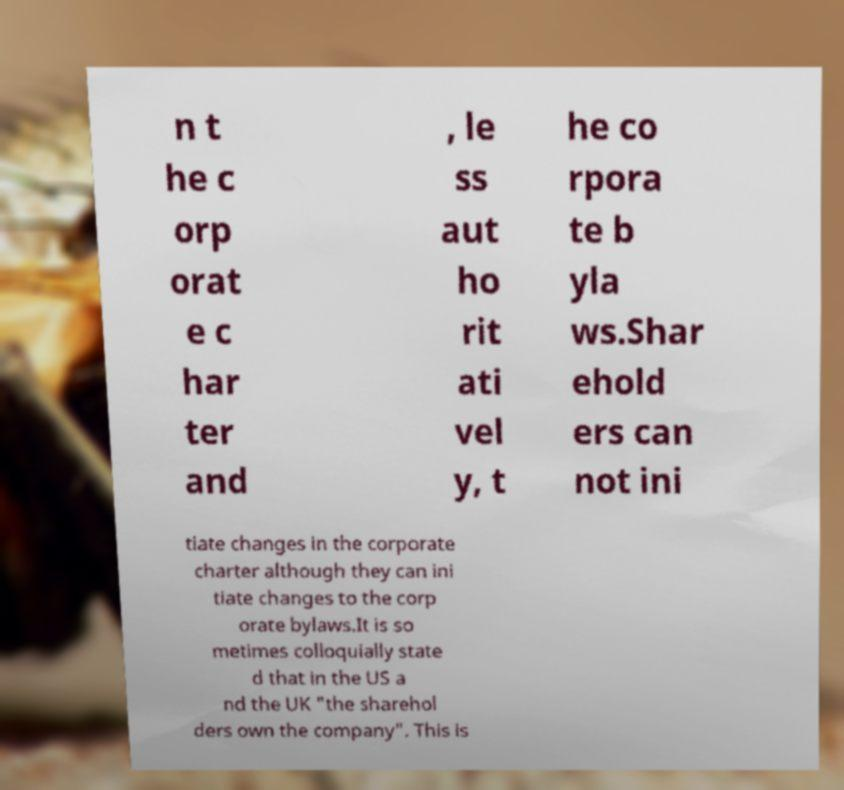For documentation purposes, I need the text within this image transcribed. Could you provide that? n t he c orp orat e c har ter and , le ss aut ho rit ati vel y, t he co rpora te b yla ws.Shar ehold ers can not ini tiate changes in the corporate charter although they can ini tiate changes to the corp orate bylaws.It is so metimes colloquially state d that in the US a nd the UK "the sharehol ders own the company". This is 